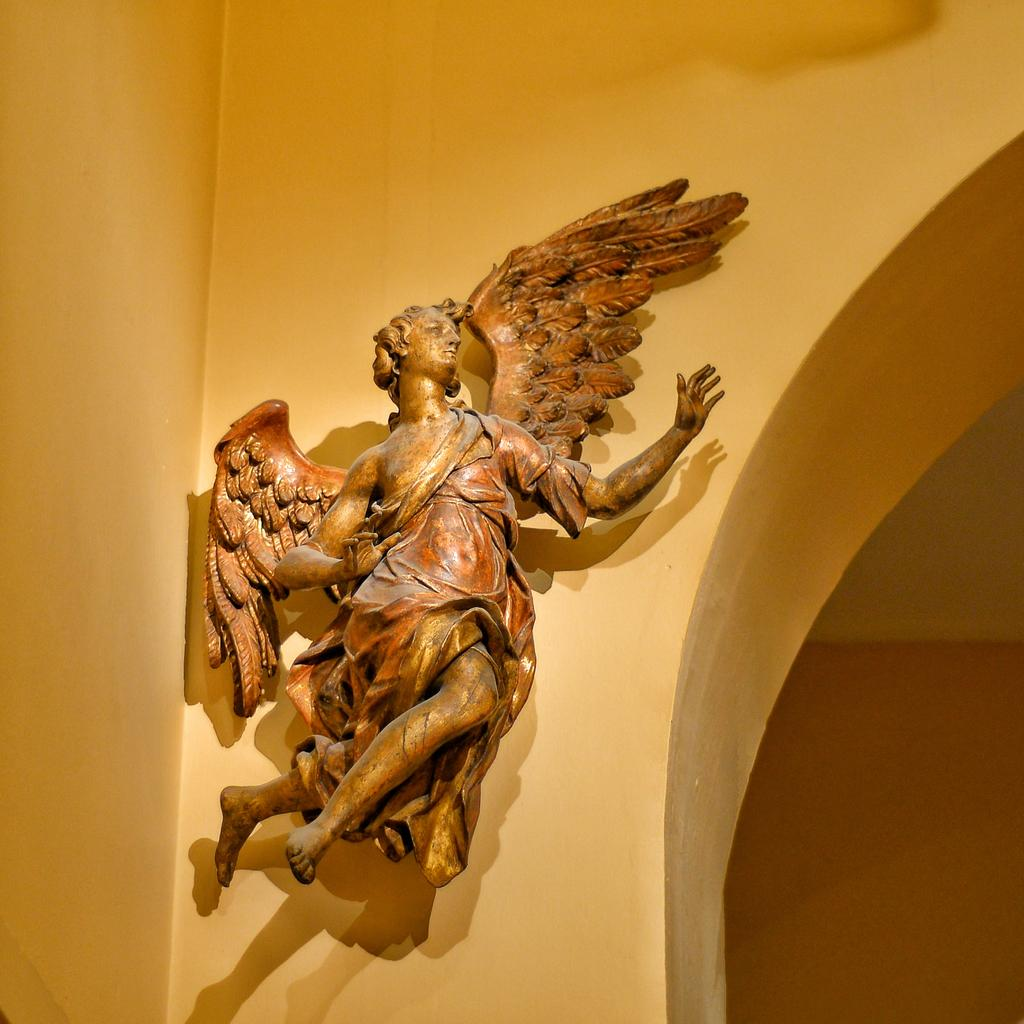What color is the wall in the image? The wall in the image is yellow. What is attached to the yellow wall? There is a brown color sculpture on the wall. What can be observed on the wall in addition to the sculpture? There are shadows visible on the wall. What type of quartz can be seen in the image? There is no quartz present in the image. Can you describe the cherry tree in the image? There is no cherry tree present in the image. 